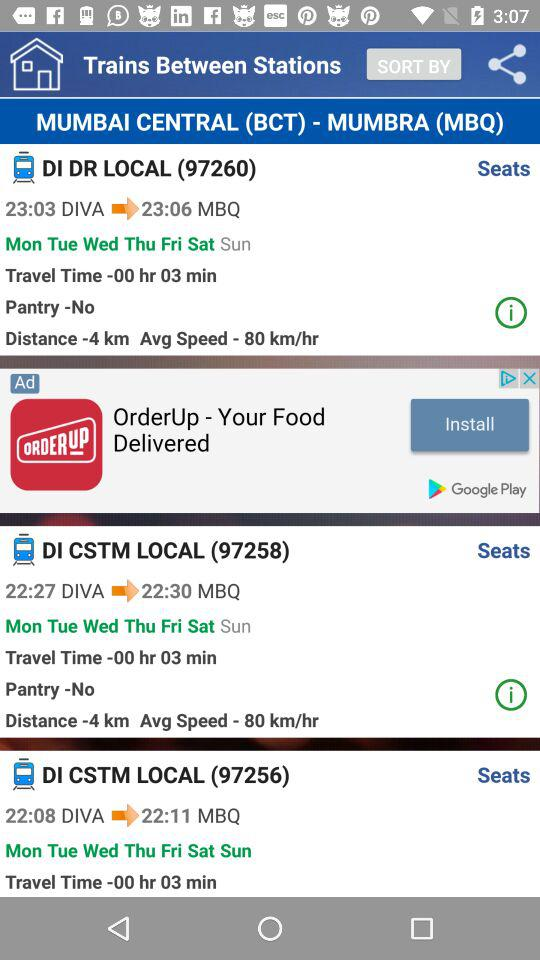What is the departure time of train "DI CSTM LOCAL (97258)"? The departure time of train "DI CSTM LOCAL (97258)" is 22:27. 